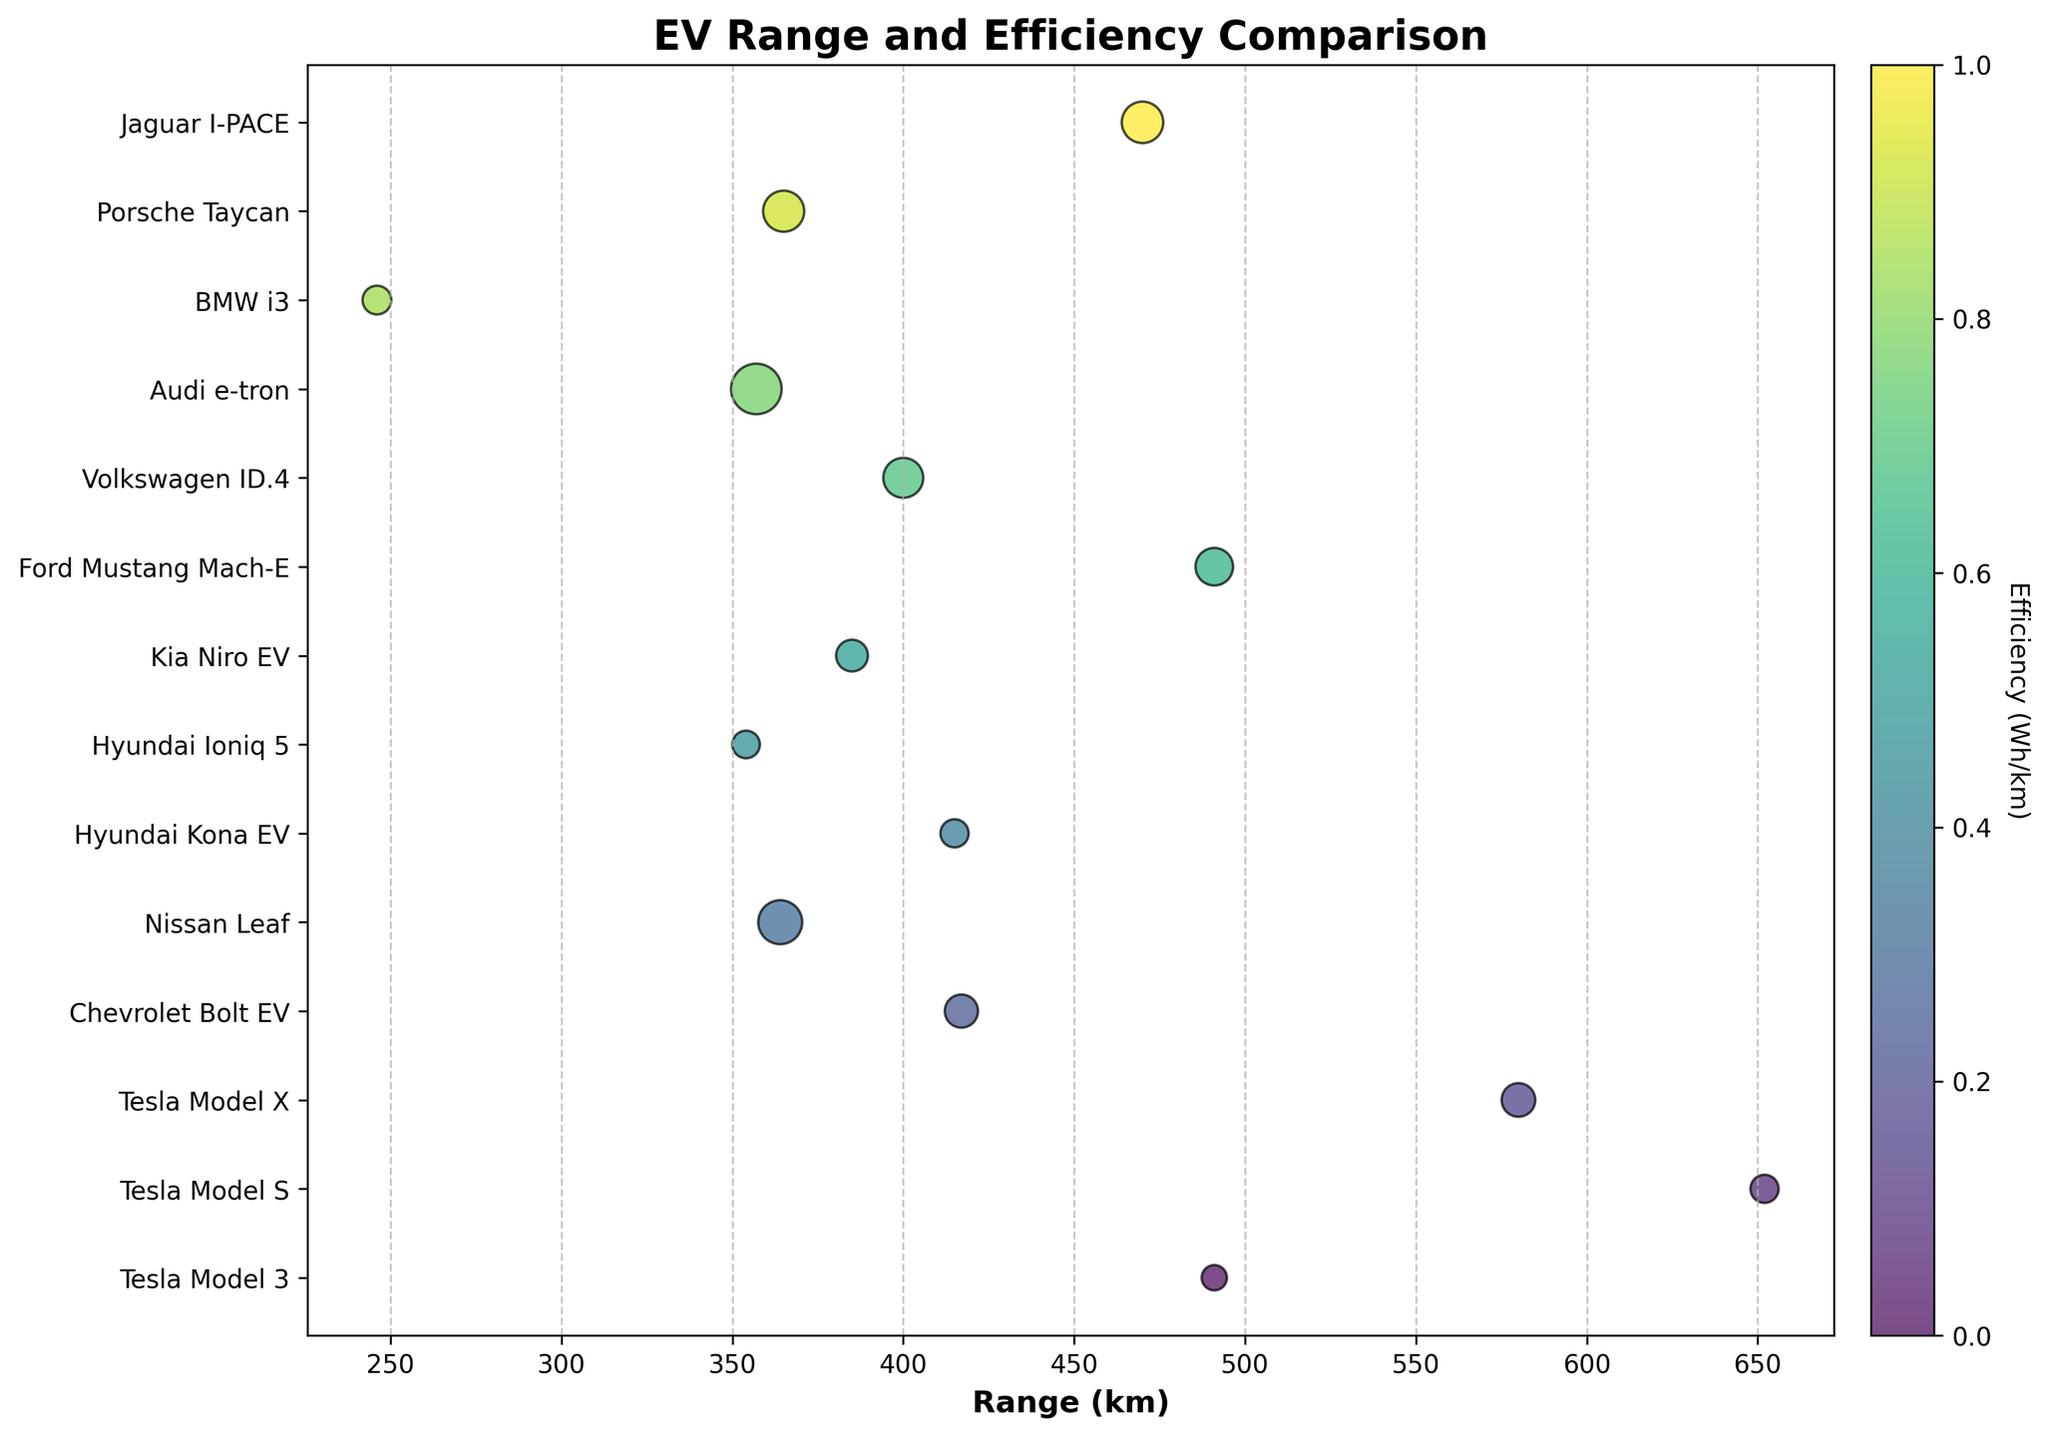What is the range of the Tesla Model 3? Locate the Tesla Model 3 on the y-axis, then read the corresponding value on the x-axis.
Answer: 491 km How many models have a range greater than 500 km? Count the instances where the range value on the x-axis is greater than 500 km.
Answer: 2 models What is the most efficient EV model? Identify the smallest marker size, as higher efficiency (lower Wh/km) is denoted by smaller marker size.
Answer: Tesla Model 3 (138 Wh/km) How does the range of the Hyundai Kona EV compare to the Ford Mustang Mach-E? Find both models on the y-axis, then compare their range values on the x-axis. Hyundai Kona EV has a range of 415 km, and Ford Mustang Mach-E has a range of 491 km.
Answer: Ford Mustang Mach-E has a greater range Which model has the highest efficiency rating among vehicles with a range under 400 km? Check models with a range under 400 km and then look for the model with the smallest marker size within this subset.
Answer: BMW i3 (144 Wh/km) What is the average range of the Tesla models? Sum the ranges of the Tesla Model 3, Model S, and Model X and divide by 3. (491 km + 652 km + 580 km) = 1723, then 1723 / 3 = 574.3 km
Answer: 574.3 km Which model has the lowest efficiency rating (highest Wh/km)? Identify the largest marker size, as a larger size indicates lower efficiency (higher Wh/km).
Answer: Audi e-tron (200 Wh/km) How does the efficiency of the Porsche Taycan compare to that of the Audi e-tron? Locate both models on the y-axis and compare their marker sizes. Porsche Taycan has an efficiency of 172 Wh/km, while the Audi e-tron has 200 Wh/km.
Answer: Porsche Taycan is more efficient What's the difference in range between the Jaguar I-PACE and the Chevrolet Bolt EV? Identify the range values for both models and calculate the difference. Jaguar I-PACE: 470 km, Chevrolet Bolt EV: 417 km. Difference: 470 km - 417 km = 53 km
Answer: 53 km Which models have both a range under 400 km and an efficiency rating above 160 Wh/km? Look for models where the range is under 400 km while simultaneously their marker sizes (efficiency ratings) are indicative of values above 160 Wh/km.
Answer: Nissan Leaf, Porsche Taycan, Audi e-tron 